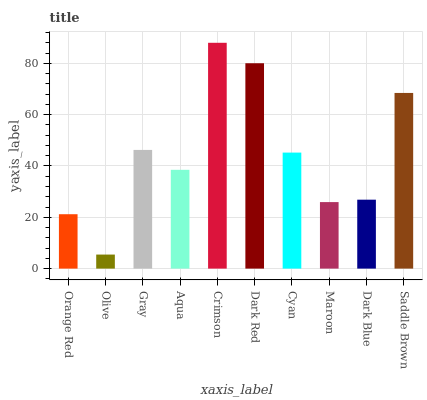Is Gray the minimum?
Answer yes or no. No. Is Gray the maximum?
Answer yes or no. No. Is Gray greater than Olive?
Answer yes or no. Yes. Is Olive less than Gray?
Answer yes or no. Yes. Is Olive greater than Gray?
Answer yes or no. No. Is Gray less than Olive?
Answer yes or no. No. Is Cyan the high median?
Answer yes or no. Yes. Is Aqua the low median?
Answer yes or no. Yes. Is Crimson the high median?
Answer yes or no. No. Is Olive the low median?
Answer yes or no. No. 